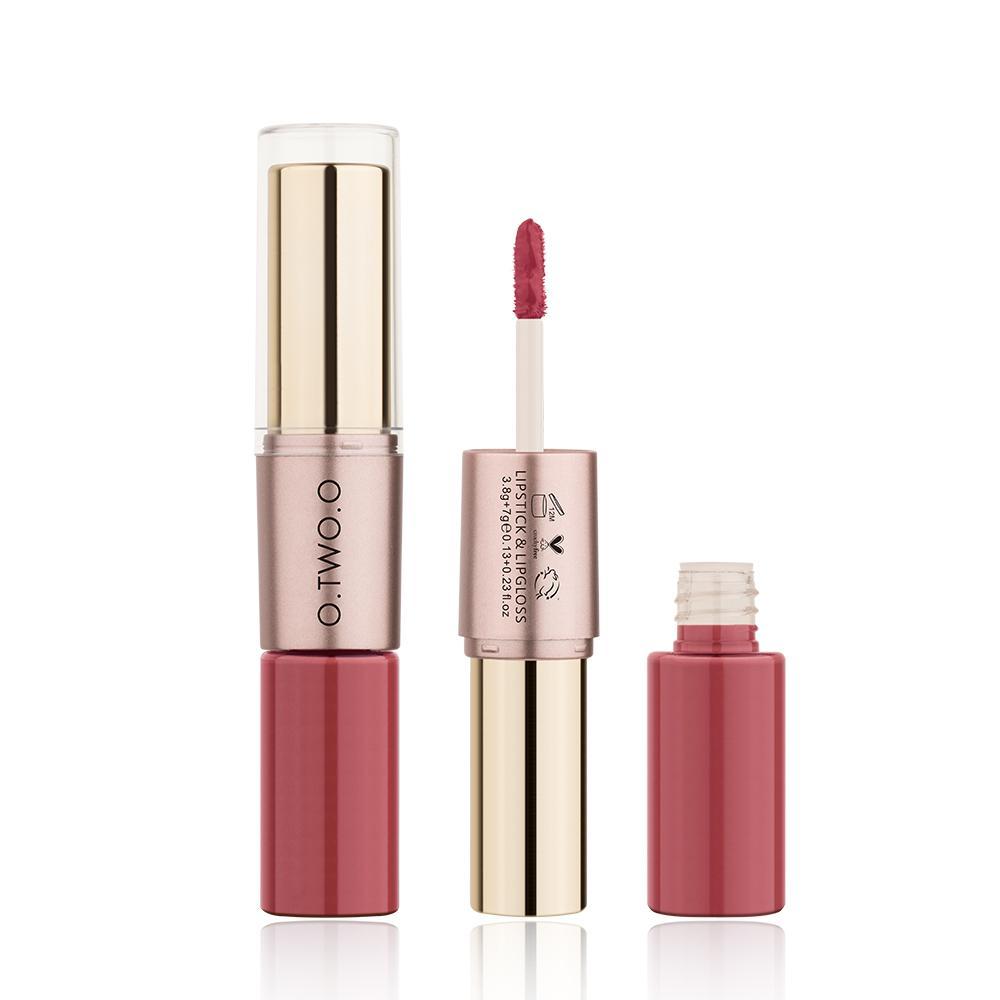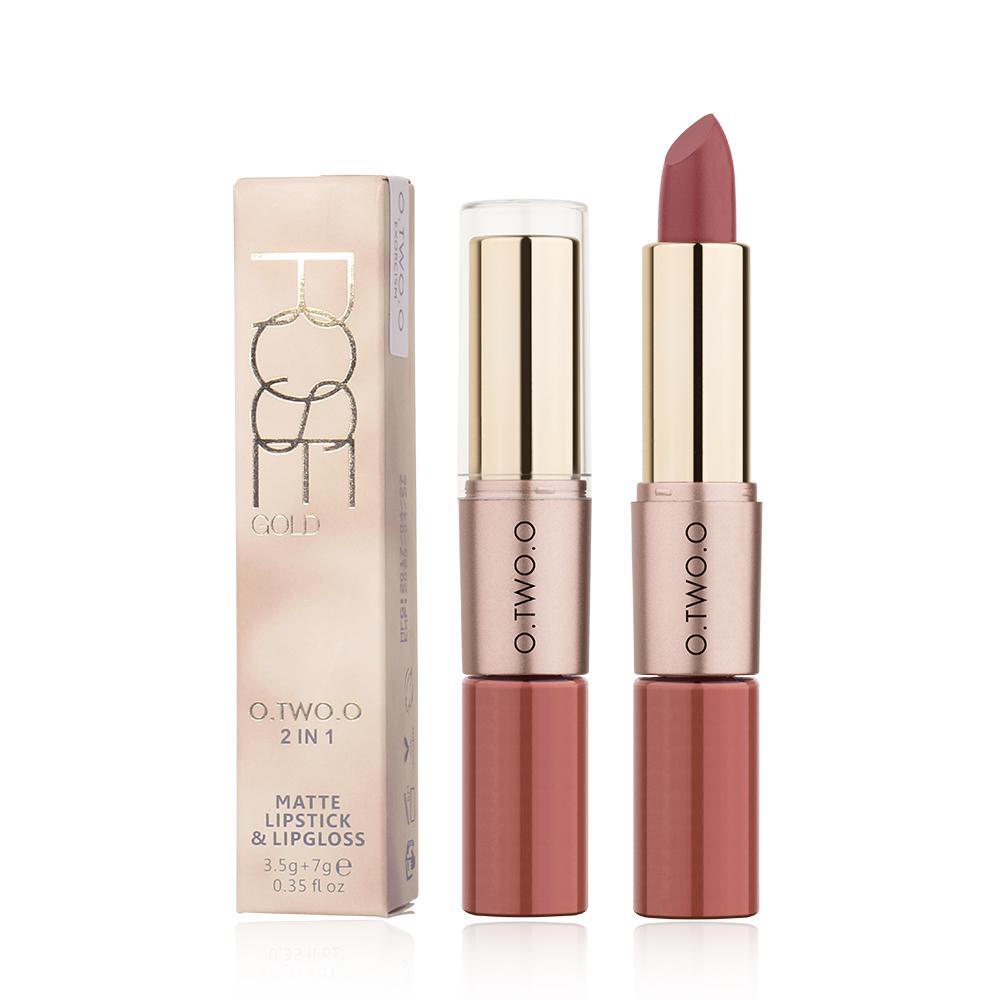The first image is the image on the left, the second image is the image on the right. Given the left and right images, does the statement "All of the products are exactly vertical." hold true? Answer yes or no. Yes. The first image is the image on the left, the second image is the image on the right. For the images shown, is this caption "Fewer than four lip products are displayed." true? Answer yes or no. No. 